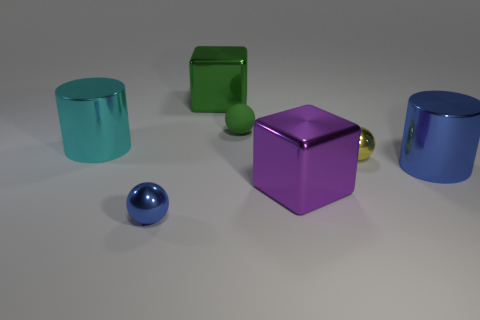Add 1 yellow metallic balls. How many objects exist? 8 Subtract all blocks. How many objects are left? 5 Add 6 matte things. How many matte things are left? 7 Add 4 purple objects. How many purple objects exist? 5 Subtract 1 yellow spheres. How many objects are left? 6 Subtract all small purple matte spheres. Subtract all large green metallic blocks. How many objects are left? 6 